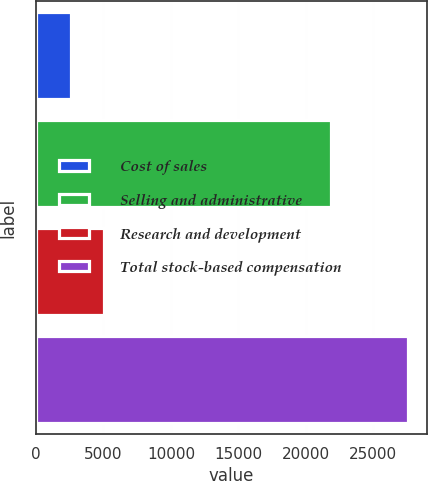Convert chart. <chart><loc_0><loc_0><loc_500><loc_500><bar_chart><fcel>Cost of sales<fcel>Selling and administrative<fcel>Research and development<fcel>Total stock-based compensation<nl><fcel>2566<fcel>21891<fcel>5067.3<fcel>27579<nl></chart> 